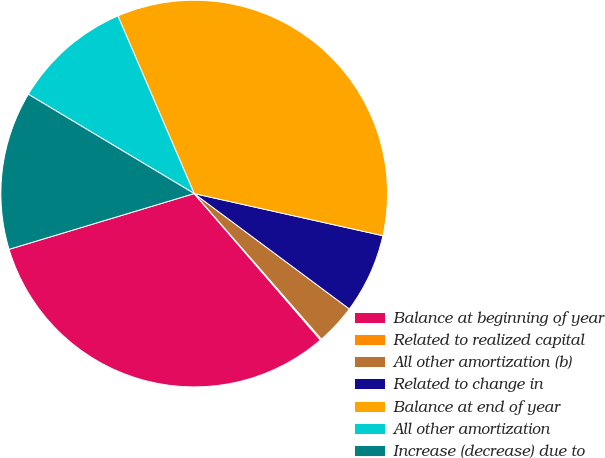Convert chart. <chart><loc_0><loc_0><loc_500><loc_500><pie_chart><fcel>Balance at beginning of year<fcel>Related to realized capital<fcel>All other amortization (b)<fcel>Related to change in<fcel>Balance at end of year<fcel>All other amortization<fcel>Increase (decrease) due to<nl><fcel>31.67%<fcel>0.11%<fcel>3.39%<fcel>6.68%<fcel>34.95%<fcel>9.96%<fcel>13.24%<nl></chart> 